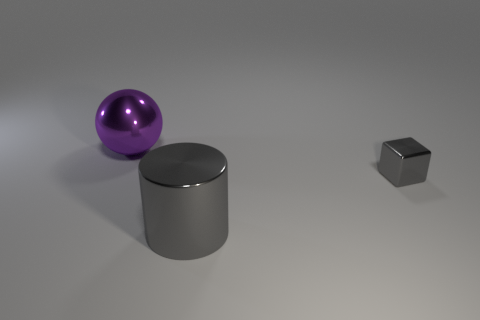What is the material of the cube that is the same color as the big metallic cylinder?
Provide a succinct answer. Metal. There is a big thing that is the same color as the tiny metal block; what is its shape?
Make the answer very short. Cylinder. Do the tiny shiny object and the metallic cylinder have the same color?
Offer a very short reply. Yes. How many gray shiny things are both on the left side of the tiny block and on the right side of the gray shiny cylinder?
Offer a very short reply. 0. There is a big object that is in front of the big metallic object to the left of the big metal cylinder; how many big shiny spheres are in front of it?
Offer a terse response. 0. What size is the shiny cylinder that is the same color as the small object?
Provide a succinct answer. Large. The tiny gray thing has what shape?
Offer a terse response. Cube. How many purple things have the same material as the cube?
Your answer should be compact. 1. There is a sphere that is made of the same material as the gray cylinder; what color is it?
Provide a succinct answer. Purple. Do the purple metallic sphere and the gray metal thing that is on the left side of the small thing have the same size?
Provide a succinct answer. Yes. 